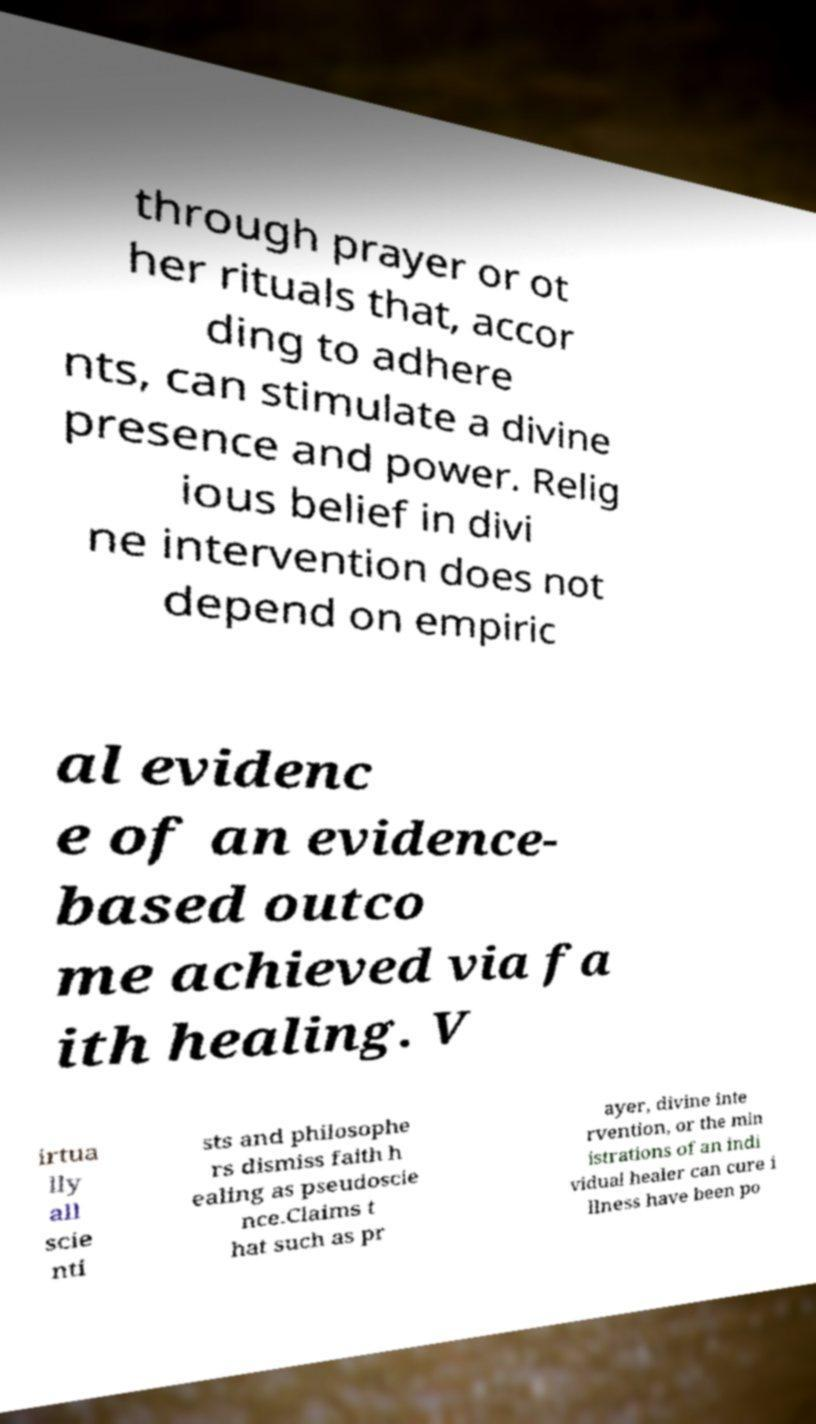Could you extract and type out the text from this image? through prayer or ot her rituals that, accor ding to adhere nts, can stimulate a divine presence and power. Relig ious belief in divi ne intervention does not depend on empiric al evidenc e of an evidence- based outco me achieved via fa ith healing. V irtua lly all scie nti sts and philosophe rs dismiss faith h ealing as pseudoscie nce.Claims t hat such as pr ayer, divine inte rvention, or the min istrations of an indi vidual healer can cure i llness have been po 